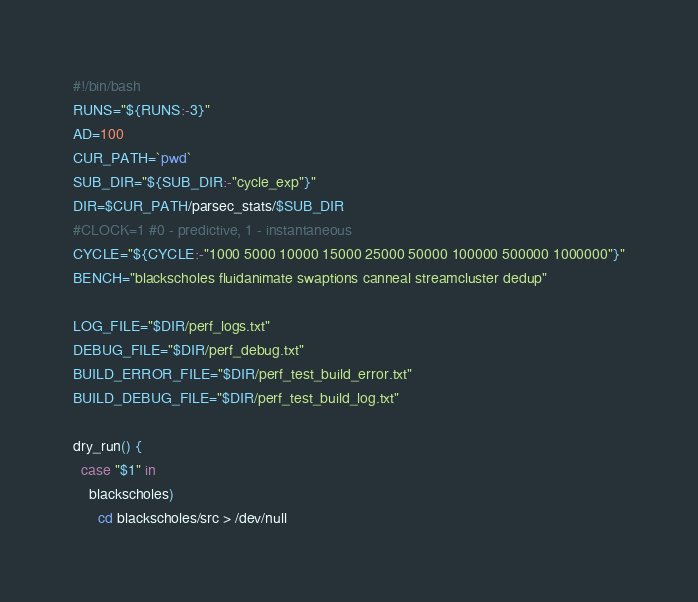<code> <loc_0><loc_0><loc_500><loc_500><_Bash_>#!/bin/bash
RUNS="${RUNS:-3}"
AD=100
CUR_PATH=`pwd`
SUB_DIR="${SUB_DIR:-"cycle_exp"}"
DIR=$CUR_PATH/parsec_stats/$SUB_DIR
#CLOCK=1 #0 - predictive, 1 - instantaneous
CYCLE="${CYCLE:-"1000 5000 10000 15000 25000 50000 100000 500000 1000000"}"
BENCH="blackscholes fluidanimate swaptions canneal streamcluster dedup"

LOG_FILE="$DIR/perf_logs.txt"
DEBUG_FILE="$DIR/perf_debug.txt"
BUILD_ERROR_FILE="$DIR/perf_test_build_error.txt"
BUILD_DEBUG_FILE="$DIR/perf_test_build_log.txt"

dry_run() {
  case "$1" in
    blackscholes)
      cd blackscholes/src > /dev/null</code> 